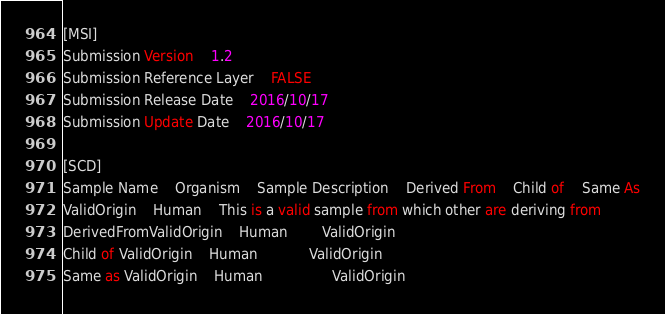Convert code to text. <code><loc_0><loc_0><loc_500><loc_500><_SQL_>[MSI]									
Submission Version	1.2								
Submission Reference Layer	FALSE								
Submission Release Date	2016/10/17								
Submission Update Date	2016/10/17								
									
[SCD]									
Sample Name	Organism	Sample Description	Derived From	Child of	Same As
ValidOrigin	Human	This is a valid sample from which other are deriving from
DerivedFromValidOrigin	Human		ValidOrigin
Child of ValidOrigin	Human			ValidOrigin
Same as ValidOrigin	Human				ValidOrigin
</code> 